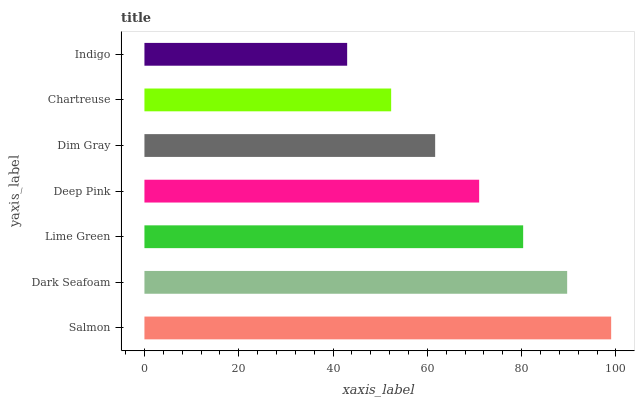Is Indigo the minimum?
Answer yes or no. Yes. Is Salmon the maximum?
Answer yes or no. Yes. Is Dark Seafoam the minimum?
Answer yes or no. No. Is Dark Seafoam the maximum?
Answer yes or no. No. Is Salmon greater than Dark Seafoam?
Answer yes or no. Yes. Is Dark Seafoam less than Salmon?
Answer yes or no. Yes. Is Dark Seafoam greater than Salmon?
Answer yes or no. No. Is Salmon less than Dark Seafoam?
Answer yes or no. No. Is Deep Pink the high median?
Answer yes or no. Yes. Is Deep Pink the low median?
Answer yes or no. Yes. Is Indigo the high median?
Answer yes or no. No. Is Chartreuse the low median?
Answer yes or no. No. 